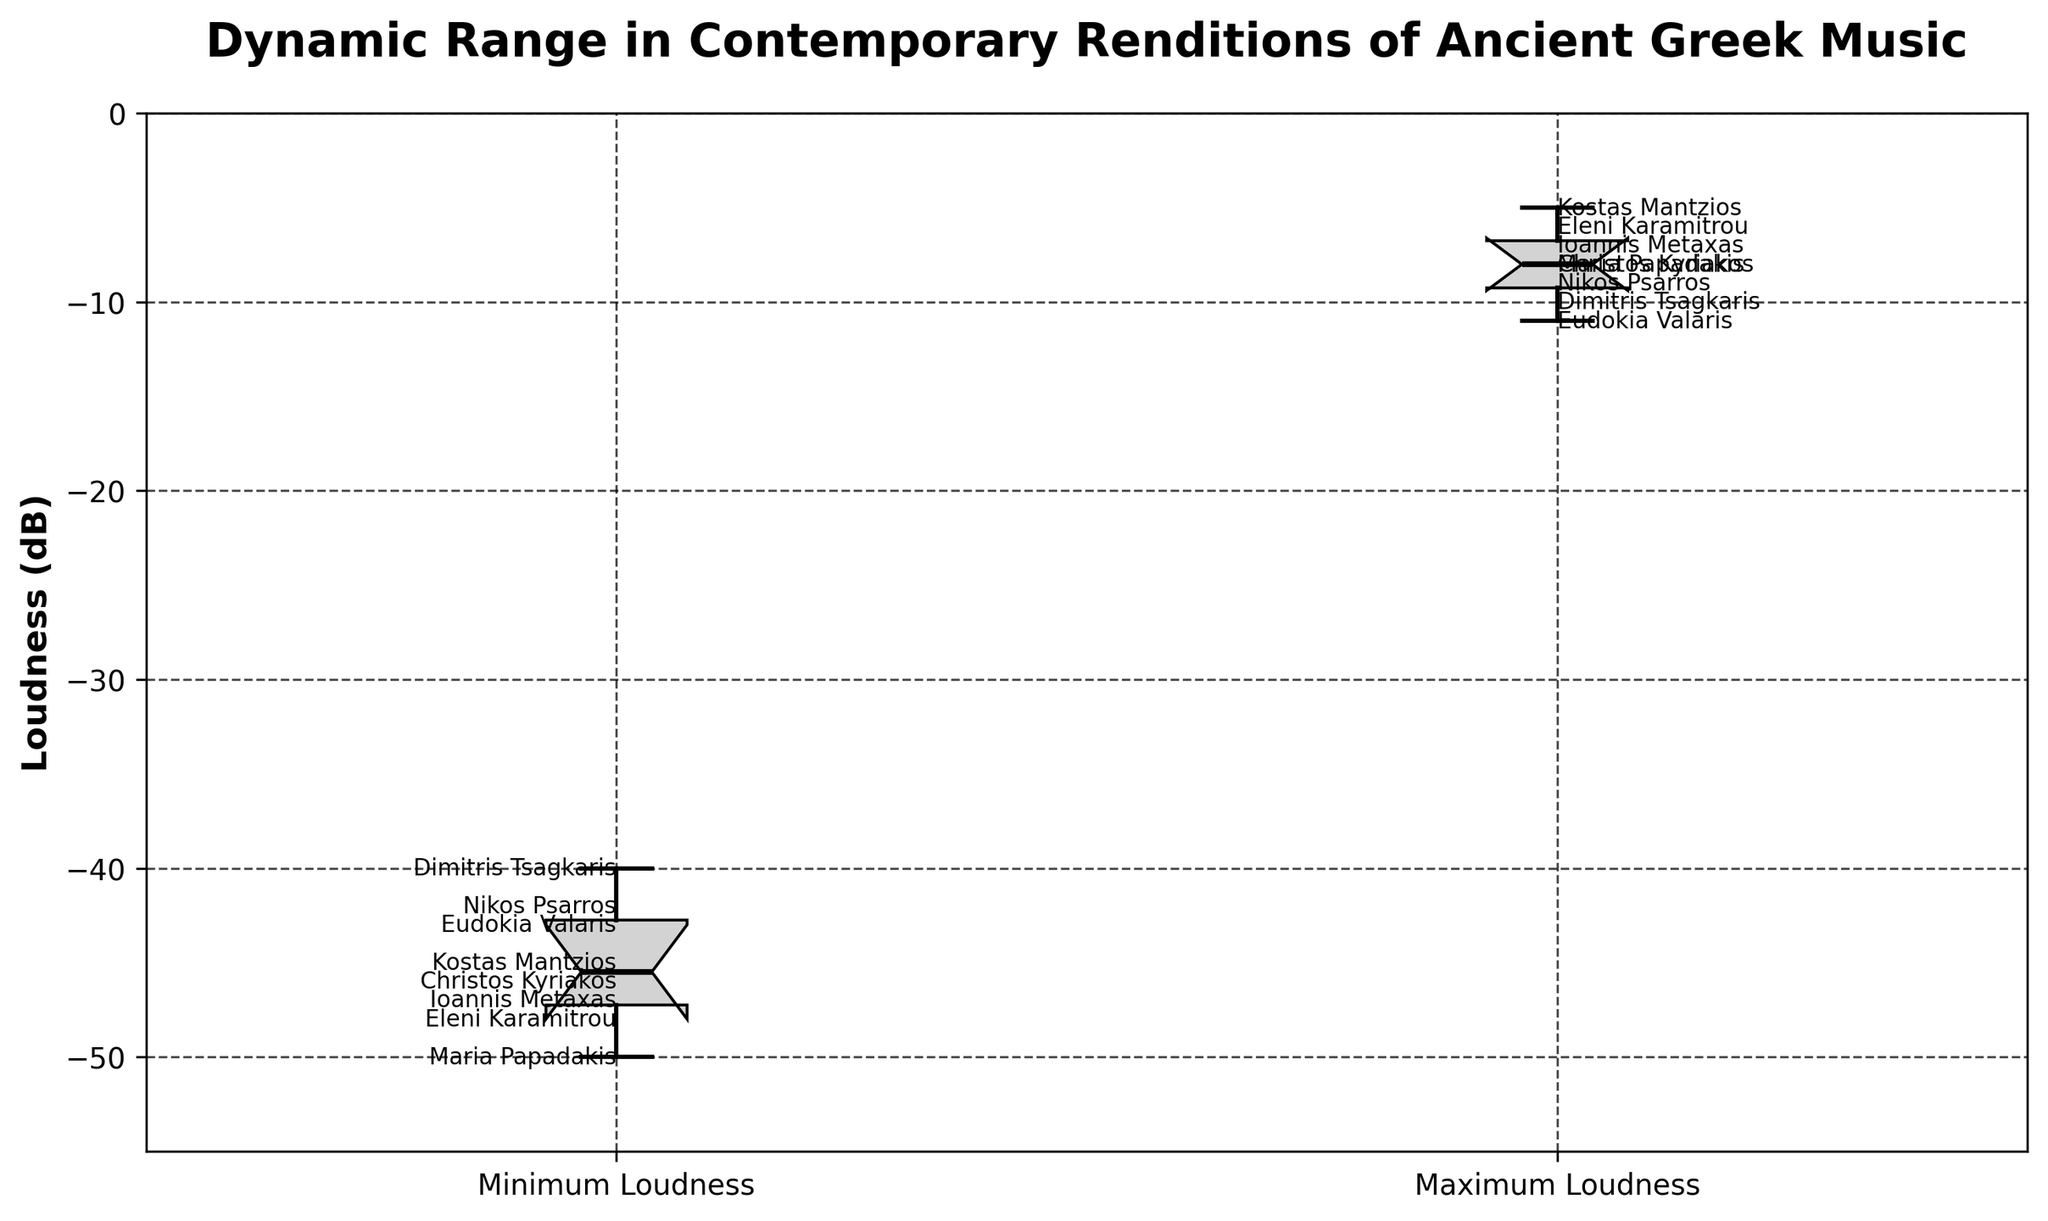How many musical pieces are analyzed in the figure? Count the number of data points, each represented by a minimum and maximum loudness entry. The total number of different compositions (data points) is 8.
Answer: 8 What is the title of this figure? Read the title at the top of the figure, which describes its content and intent.
Answer: Dynamic Range in Contemporary Renditions of Ancient Greek Music What is the range of the vertical axis? Look at the vertical axis labels to determine the minimum and maximum values it covers. The axis ranges from -55 dB to 0 dB.
Answer: -55 to 0 dB What pieces show the highest and lowest maximum loudness? Compare the maximum loudness data points. "The Odes of Pindar" has the highest maximum loudness at -5 dB, and "The Iliad Chant" has the lowest maximum loudness at -11 dB.
Answer: "The Odes of Pindar" and "The Iliad Chant" What is the median value for the minimum loudness? The notch in the minimum loudness box represents the median, closest to -46 dB.
Answer: -46 dB Is the median maximum loudness greater or less than the median minimum loudness? Compare the notch locations in both box plots. The median maximum loudness is slightly higher, at around -8 dB, compared to the median minimum loudness at -46 dB.
Answer: Greater Which piece has the smallest dynamic range? Calculate the dynamic range by subtracting the maximum loudness from the minimum loudness for each piece. "Hymn to Apollo" has the smallest range, 30 dB (-10 - (-40) = 30 dB).
Answer: "Hymn to Apollo" Which piece has the largest dynamic range? Calculate the dynamic range for each piece and identify the largest. "The Myth of Orpheus" has the largest range, 42 dB (-8 - (-50) = 42 dB).
Answer: "The Myth of Orpheus" Do all pieces lie within the whiskers for both minimum and maximum loudness values? Examine the whiskers and points (fliers) outside the main boxes; all points should be within the whiskers for both minimum and maximum loudness, suggesting no outliers. Yes, all pieces are within whiskers for both attributes.
Answer: Yes 